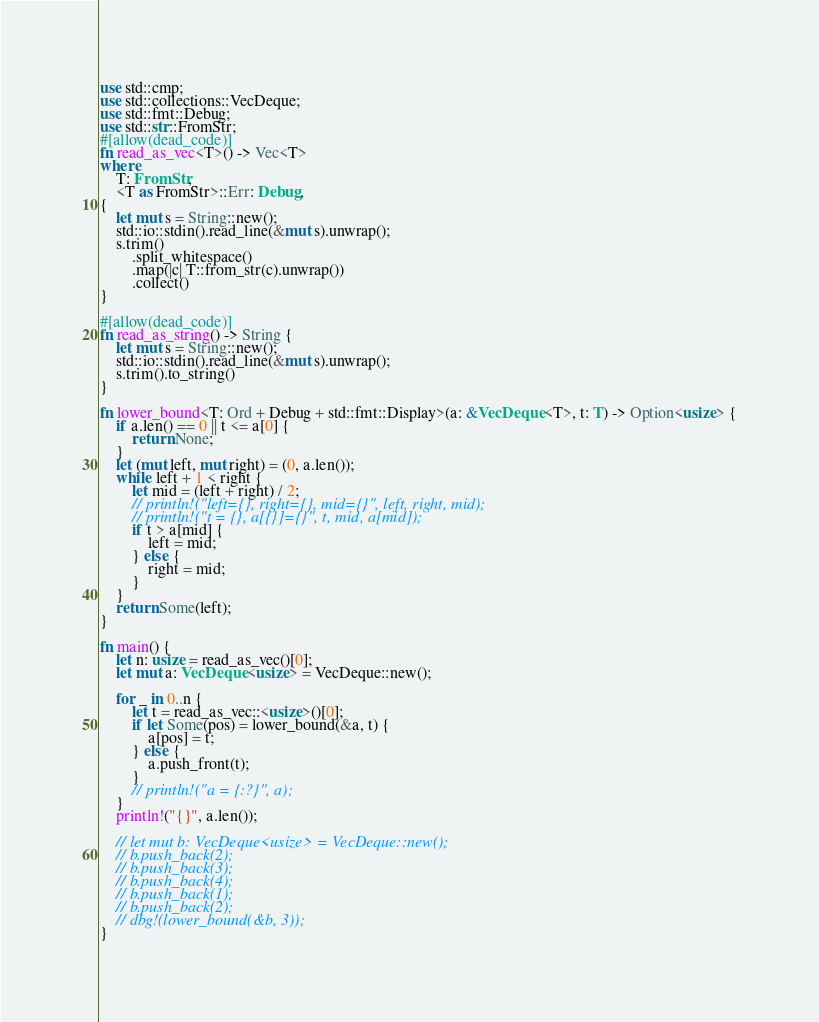<code> <loc_0><loc_0><loc_500><loc_500><_Rust_>use std::cmp;
use std::collections::VecDeque;
use std::fmt::Debug;
use std::str::FromStr;
#[allow(dead_code)]
fn read_as_vec<T>() -> Vec<T>
where
    T: FromStr,
    <T as FromStr>::Err: Debug,
{
    let mut s = String::new();
    std::io::stdin().read_line(&mut s).unwrap();
    s.trim()
        .split_whitespace()
        .map(|c| T::from_str(c).unwrap())
        .collect()
}

#[allow(dead_code)]
fn read_as_string() -> String {
    let mut s = String::new();
    std::io::stdin().read_line(&mut s).unwrap();
    s.trim().to_string()
}

fn lower_bound<T: Ord + Debug + std::fmt::Display>(a: &VecDeque<T>, t: T) -> Option<usize> {
    if a.len() == 0 || t <= a[0] {
        return None;
    }
    let (mut left, mut right) = (0, a.len());
    while left + 1 < right {
        let mid = (left + right) / 2;
        // println!("left={}, right={}, mid={}", left, right, mid);
        // println!("t = {}, a[{}]={}", t, mid, a[mid]);
        if t > a[mid] {
            left = mid;
        } else {
            right = mid;
        }
    }
    return Some(left);
}

fn main() {
    let n: usize = read_as_vec()[0];
    let mut a: VecDeque<usize> = VecDeque::new();

    for _ in 0..n {
        let t = read_as_vec::<usize>()[0];
        if let Some(pos) = lower_bound(&a, t) {
            a[pos] = t;
        } else {
            a.push_front(t);
        }
        // println!("a = {:?}", a);
    }
    println!("{}", a.len());

    // let mut b: VecDeque<usize> = VecDeque::new();
    // b.push_back(2);
    // b.push_back(3);
    // b.push_back(4);
    // b.push_back(1);
    // b.push_back(2);
    // dbg!(lower_bound(&b, 3));
}
</code> 